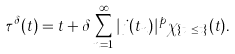<formula> <loc_0><loc_0><loc_500><loc_500>\tau ^ { \delta } ( t ) = t + \delta \sum _ { n = 1 } ^ { \infty } | j ( t _ { n } ) | ^ { p } \chi _ { \{ t _ { n } \leq t \} } ( t ) .</formula> 